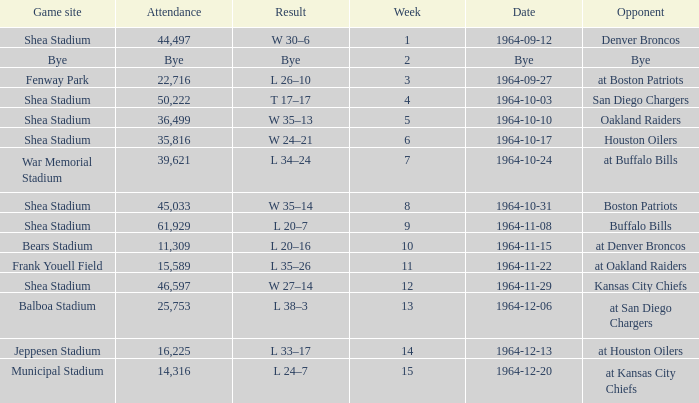What's the result of the game against Bye? Bye. 